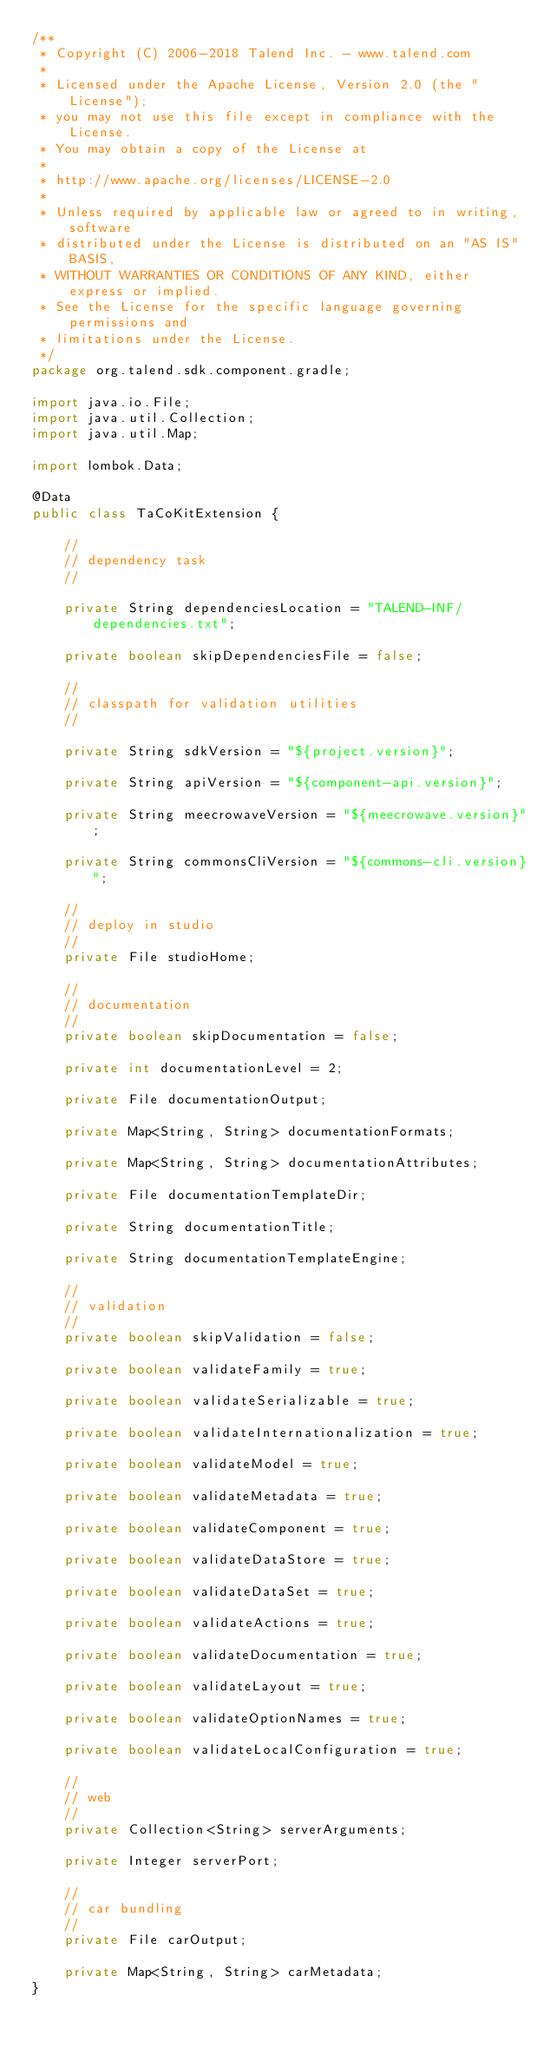<code> <loc_0><loc_0><loc_500><loc_500><_Java_>/**
 * Copyright (C) 2006-2018 Talend Inc. - www.talend.com
 *
 * Licensed under the Apache License, Version 2.0 (the "License");
 * you may not use this file except in compliance with the License.
 * You may obtain a copy of the License at
 *
 * http://www.apache.org/licenses/LICENSE-2.0
 *
 * Unless required by applicable law or agreed to in writing, software
 * distributed under the License is distributed on an "AS IS" BASIS,
 * WITHOUT WARRANTIES OR CONDITIONS OF ANY KIND, either express or implied.
 * See the License for the specific language governing permissions and
 * limitations under the License.
 */
package org.talend.sdk.component.gradle;

import java.io.File;
import java.util.Collection;
import java.util.Map;

import lombok.Data;

@Data
public class TaCoKitExtension {

    //
    // dependency task
    //

    private String dependenciesLocation = "TALEND-INF/dependencies.txt";

    private boolean skipDependenciesFile = false;

    //
    // classpath for validation utilities
    //

    private String sdkVersion = "${project.version}";

    private String apiVersion = "${component-api.version}";

    private String meecrowaveVersion = "${meecrowave.version}";

    private String commonsCliVersion = "${commons-cli.version}";

    //
    // deploy in studio
    //
    private File studioHome;

    //
    // documentation
    //
    private boolean skipDocumentation = false;

    private int documentationLevel = 2;

    private File documentationOutput;

    private Map<String, String> documentationFormats;

    private Map<String, String> documentationAttributes;

    private File documentationTemplateDir;

    private String documentationTitle;

    private String documentationTemplateEngine;

    //
    // validation
    //
    private boolean skipValidation = false;

    private boolean validateFamily = true;

    private boolean validateSerializable = true;

    private boolean validateInternationalization = true;

    private boolean validateModel = true;

    private boolean validateMetadata = true;

    private boolean validateComponent = true;

    private boolean validateDataStore = true;

    private boolean validateDataSet = true;

    private boolean validateActions = true;

    private boolean validateDocumentation = true;

    private boolean validateLayout = true;

    private boolean validateOptionNames = true;

    private boolean validateLocalConfiguration = true;

    //
    // web
    //
    private Collection<String> serverArguments;

    private Integer serverPort;

    //
    // car bundling
    //
    private File carOutput;

    private Map<String, String> carMetadata;
}
</code> 